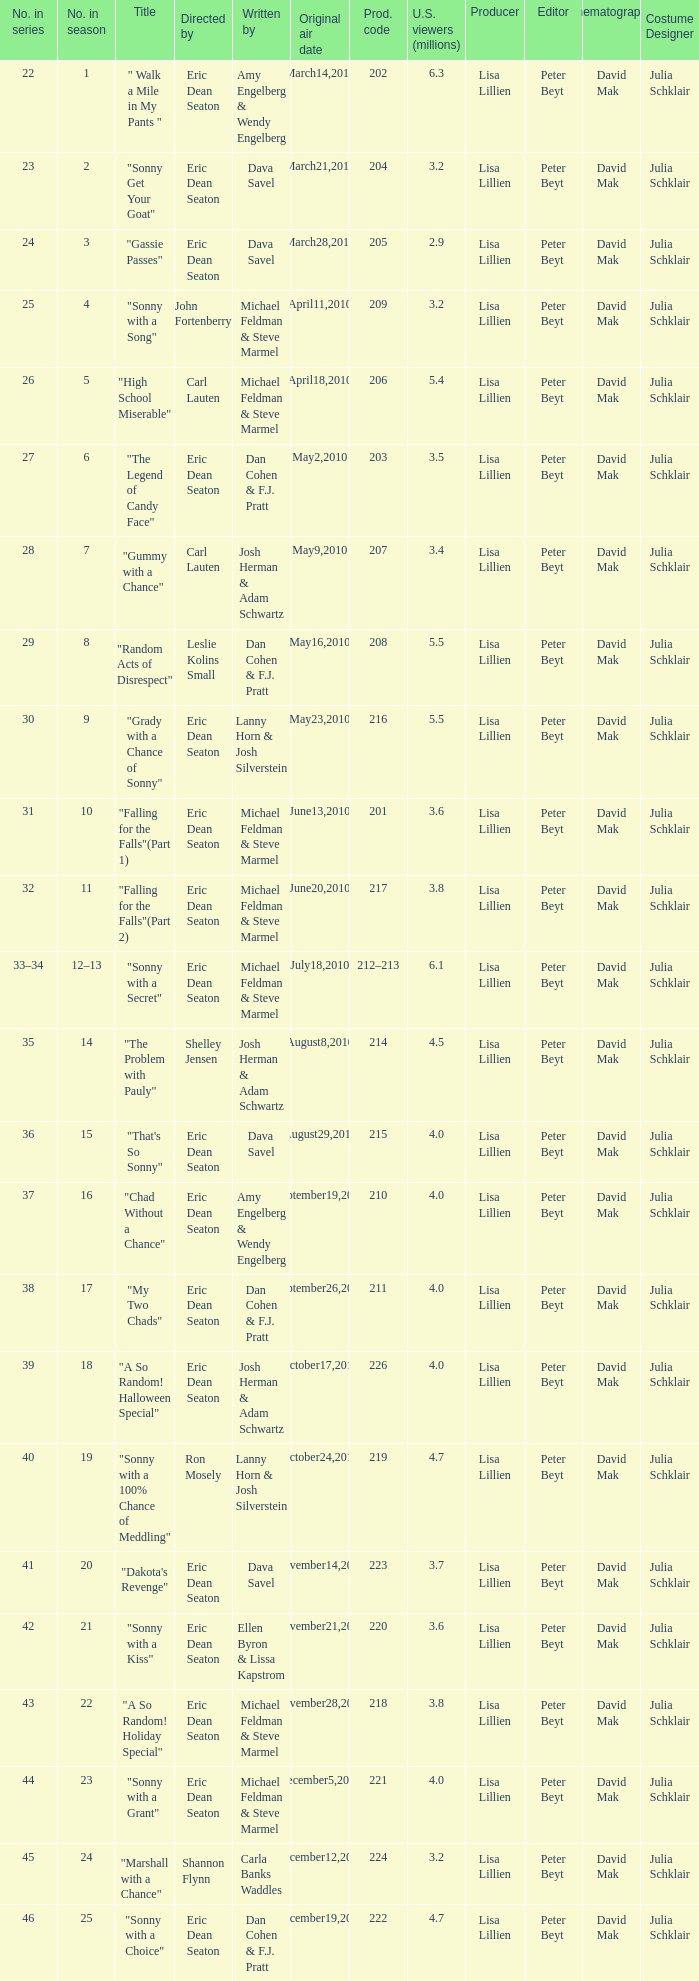Would you mind parsing the complete table? {'header': ['No. in series', 'No. in season', 'Title', 'Directed by', 'Written by', 'Original air date', 'Prod. code', 'U.S. viewers (millions)', 'Producer', 'Editor', 'Cinematographer', 'Costume Designer'], 'rows': [['22', '1', '" Walk a Mile in My Pants "', 'Eric Dean Seaton', 'Amy Engelberg & Wendy Engelberg', 'March14,2010', '202', '6.3', 'Lisa Lillien', 'Peter Beyt', 'David Mak', 'Julia Schklair'], ['23', '2', '"Sonny Get Your Goat"', 'Eric Dean Seaton', 'Dava Savel', 'March21,2010', '204', '3.2', 'Lisa Lillien', 'Peter Beyt', 'David Mak', 'Julia Schklair'], ['24', '3', '"Gassie Passes"', 'Eric Dean Seaton', 'Dava Savel', 'March28,2010', '205', '2.9', 'Lisa Lillien', 'Peter Beyt', 'David Mak', 'Julia Schklair'], ['25', '4', '"Sonny with a Song"', 'John Fortenberry', 'Michael Feldman & Steve Marmel', 'April11,2010', '209', '3.2', 'Lisa Lillien', 'Peter Beyt', 'David Mak', 'Julia Schklair'], ['26', '5', '"High School Miserable"', 'Carl Lauten', 'Michael Feldman & Steve Marmel', 'April18,2010', '206', '5.4', 'Lisa Lillien', 'Peter Beyt', 'David Mak', 'Julia Schklair'], ['27', '6', '"The Legend of Candy Face"', 'Eric Dean Seaton', 'Dan Cohen & F.J. Pratt', 'May2,2010', '203', '3.5', 'Lisa Lillien', 'Peter Beyt', 'David Mak', 'Julia Schklair'], ['28', '7', '"Gummy with a Chance"', 'Carl Lauten', 'Josh Herman & Adam Schwartz', 'May9,2010', '207', '3.4', 'Lisa Lillien', 'Peter Beyt', 'David Mak', 'Julia Schklair'], ['29', '8', '"Random Acts of Disrespect"', 'Leslie Kolins Small', 'Dan Cohen & F.J. Pratt', 'May16,2010', '208', '5.5', 'Lisa Lillien', 'Peter Beyt', 'David Mak', 'Julia Schklair'], ['30', '9', '"Grady with a Chance of Sonny"', 'Eric Dean Seaton', 'Lanny Horn & Josh Silverstein', 'May23,2010', '216', '5.5', 'Lisa Lillien', 'Peter Beyt', 'David Mak', 'Julia Schklair'], ['31', '10', '"Falling for the Falls"(Part 1)', 'Eric Dean Seaton', 'Michael Feldman & Steve Marmel', 'June13,2010', '201', '3.6', 'Lisa Lillien', 'Peter Beyt', 'David Mak', 'Julia Schklair'], ['32', '11', '"Falling for the Falls"(Part 2)', 'Eric Dean Seaton', 'Michael Feldman & Steve Marmel', 'June20,2010', '217', '3.8', 'Lisa Lillien', 'Peter Beyt', 'David Mak', 'Julia Schklair'], ['33–34', '12–13', '"Sonny with a Secret"', 'Eric Dean Seaton', 'Michael Feldman & Steve Marmel', 'July18,2010', '212–213', '6.1', 'Lisa Lillien', 'Peter Beyt', 'David Mak', 'Julia Schklair'], ['35', '14', '"The Problem with Pauly"', 'Shelley Jensen', 'Josh Herman & Adam Schwartz', 'August8,2010', '214', '4.5', 'Lisa Lillien', 'Peter Beyt', 'David Mak', 'Julia Schklair'], ['36', '15', '"That\'s So Sonny"', 'Eric Dean Seaton', 'Dava Savel', 'August29,2010', '215', '4.0', 'Lisa Lillien', 'Peter Beyt', 'David Mak', 'Julia Schklair'], ['37', '16', '"Chad Without a Chance"', 'Eric Dean Seaton', 'Amy Engelberg & Wendy Engelberg', 'September19,2010', '210', '4.0', 'Lisa Lillien', 'Peter Beyt', 'David Mak', 'Julia Schklair'], ['38', '17', '"My Two Chads"', 'Eric Dean Seaton', 'Dan Cohen & F.J. Pratt', 'September26,2010', '211', '4.0', 'Lisa Lillien', 'Peter Beyt', 'David Mak', 'Julia Schklair'], ['39', '18', '"A So Random! Halloween Special"', 'Eric Dean Seaton', 'Josh Herman & Adam Schwartz', 'October17,2010', '226', '4.0', 'Lisa Lillien', 'Peter Beyt', 'David Mak', 'Julia Schklair'], ['40', '19', '"Sonny with a 100% Chance of Meddling"', 'Ron Mosely', 'Lanny Horn & Josh Silverstein', 'October24,2010', '219', '4.7', 'Lisa Lillien', 'Peter Beyt', 'David Mak', 'Julia Schklair'], ['41', '20', '"Dakota\'s Revenge"', 'Eric Dean Seaton', 'Dava Savel', 'November14,2010', '223', '3.7', 'Lisa Lillien', 'Peter Beyt', 'David Mak', 'Julia Schklair'], ['42', '21', '"Sonny with a Kiss"', 'Eric Dean Seaton', 'Ellen Byron & Lissa Kapstrom', 'November21,2010', '220', '3.6', 'Lisa Lillien', 'Peter Beyt', 'David Mak', 'Julia Schklair'], ['43', '22', '"A So Random! Holiday Special"', 'Eric Dean Seaton', 'Michael Feldman & Steve Marmel', 'November28,2010', '218', '3.8', 'Lisa Lillien', 'Peter Beyt', 'David Mak', 'Julia Schklair'], ['44', '23', '"Sonny with a Grant"', 'Eric Dean Seaton', 'Michael Feldman & Steve Marmel', 'December5,2010', '221', '4.0', 'Lisa Lillien', 'Peter Beyt', 'David Mak', 'Julia Schklair'], ['45', '24', '"Marshall with a Chance"', 'Shannon Flynn', 'Carla Banks Waddles', 'December12,2010', '224', '3.2', 'Lisa Lillien', 'Peter Beyt', 'David Mak', 'Julia Schklair'], ['46', '25', '"Sonny with a Choice"', 'Eric Dean Seaton', 'Dan Cohen & F.J. Pratt', 'December19,2010', '222', '4.7', 'Lisa Lillien', 'Peter Beyt', 'David Mak', 'Julia Schklair']]} How man episodes in the season were titled "that's so sonny"? 1.0. 